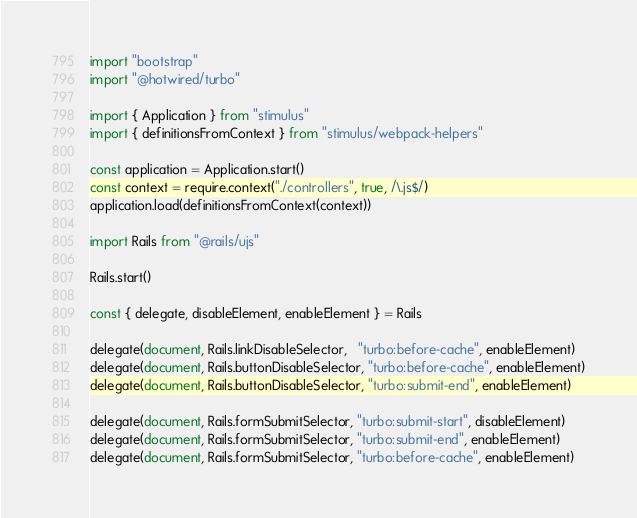<code> <loc_0><loc_0><loc_500><loc_500><_JavaScript_>import "bootstrap"
import "@hotwired/turbo"

import { Application } from "stimulus"
import { definitionsFromContext } from "stimulus/webpack-helpers"

const application = Application.start()
const context = require.context("./controllers", true, /\.js$/)
application.load(definitionsFromContext(context))

import Rails from "@rails/ujs"

Rails.start()

const { delegate, disableElement, enableElement } = Rails

delegate(document, Rails.linkDisableSelector,   "turbo:before-cache", enableElement)
delegate(document, Rails.buttonDisableSelector, "turbo:before-cache", enableElement)
delegate(document, Rails.buttonDisableSelector, "turbo:submit-end", enableElement)

delegate(document, Rails.formSubmitSelector, "turbo:submit-start", disableElement)
delegate(document, Rails.formSubmitSelector, "turbo:submit-end", enableElement)
delegate(document, Rails.formSubmitSelector, "turbo:before-cache", enableElement)

</code> 